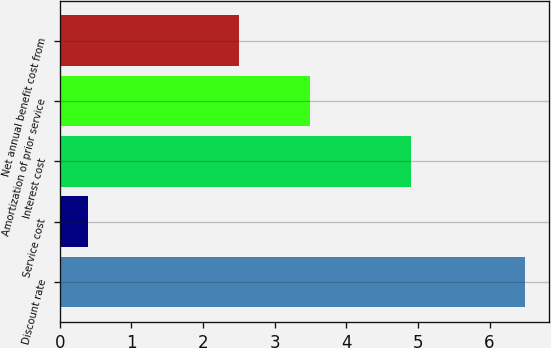Convert chart to OTSL. <chart><loc_0><loc_0><loc_500><loc_500><bar_chart><fcel>Discount rate<fcel>Service cost<fcel>Interest cost<fcel>Amortization of prior service<fcel>Net annual benefit cost from<nl><fcel>6.5<fcel>0.4<fcel>4.9<fcel>3.5<fcel>2.5<nl></chart> 